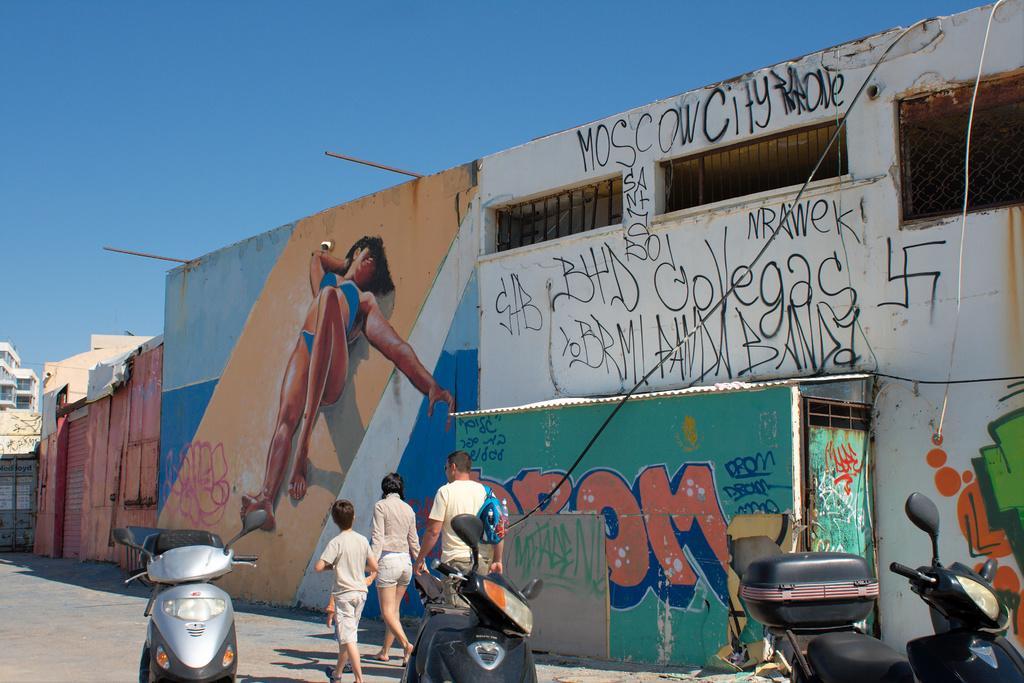Please provide a concise description of this image. In the image there is a wall and on the wall there are some paintings and different alphabets, there are three people walking beside that wall and behind them there are three vehicles parked on the land, in the background there is a building. 